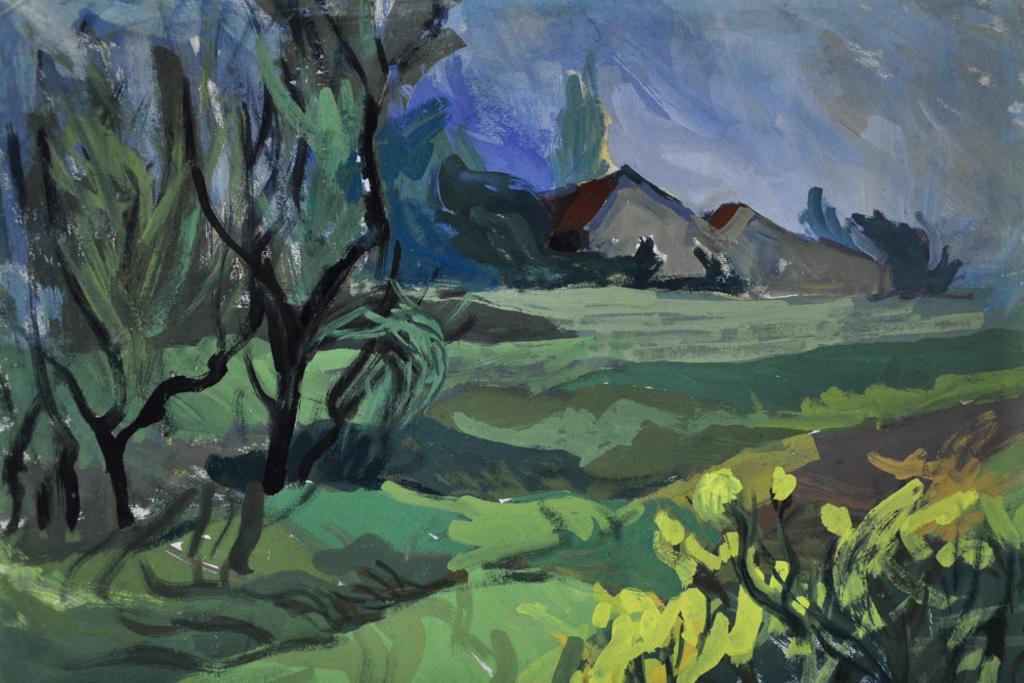Describe this image in one or two sentences. This image is a painting. In this painting there are trees and sheds. At the bottom there is grass and plants. In the background there is sky. 